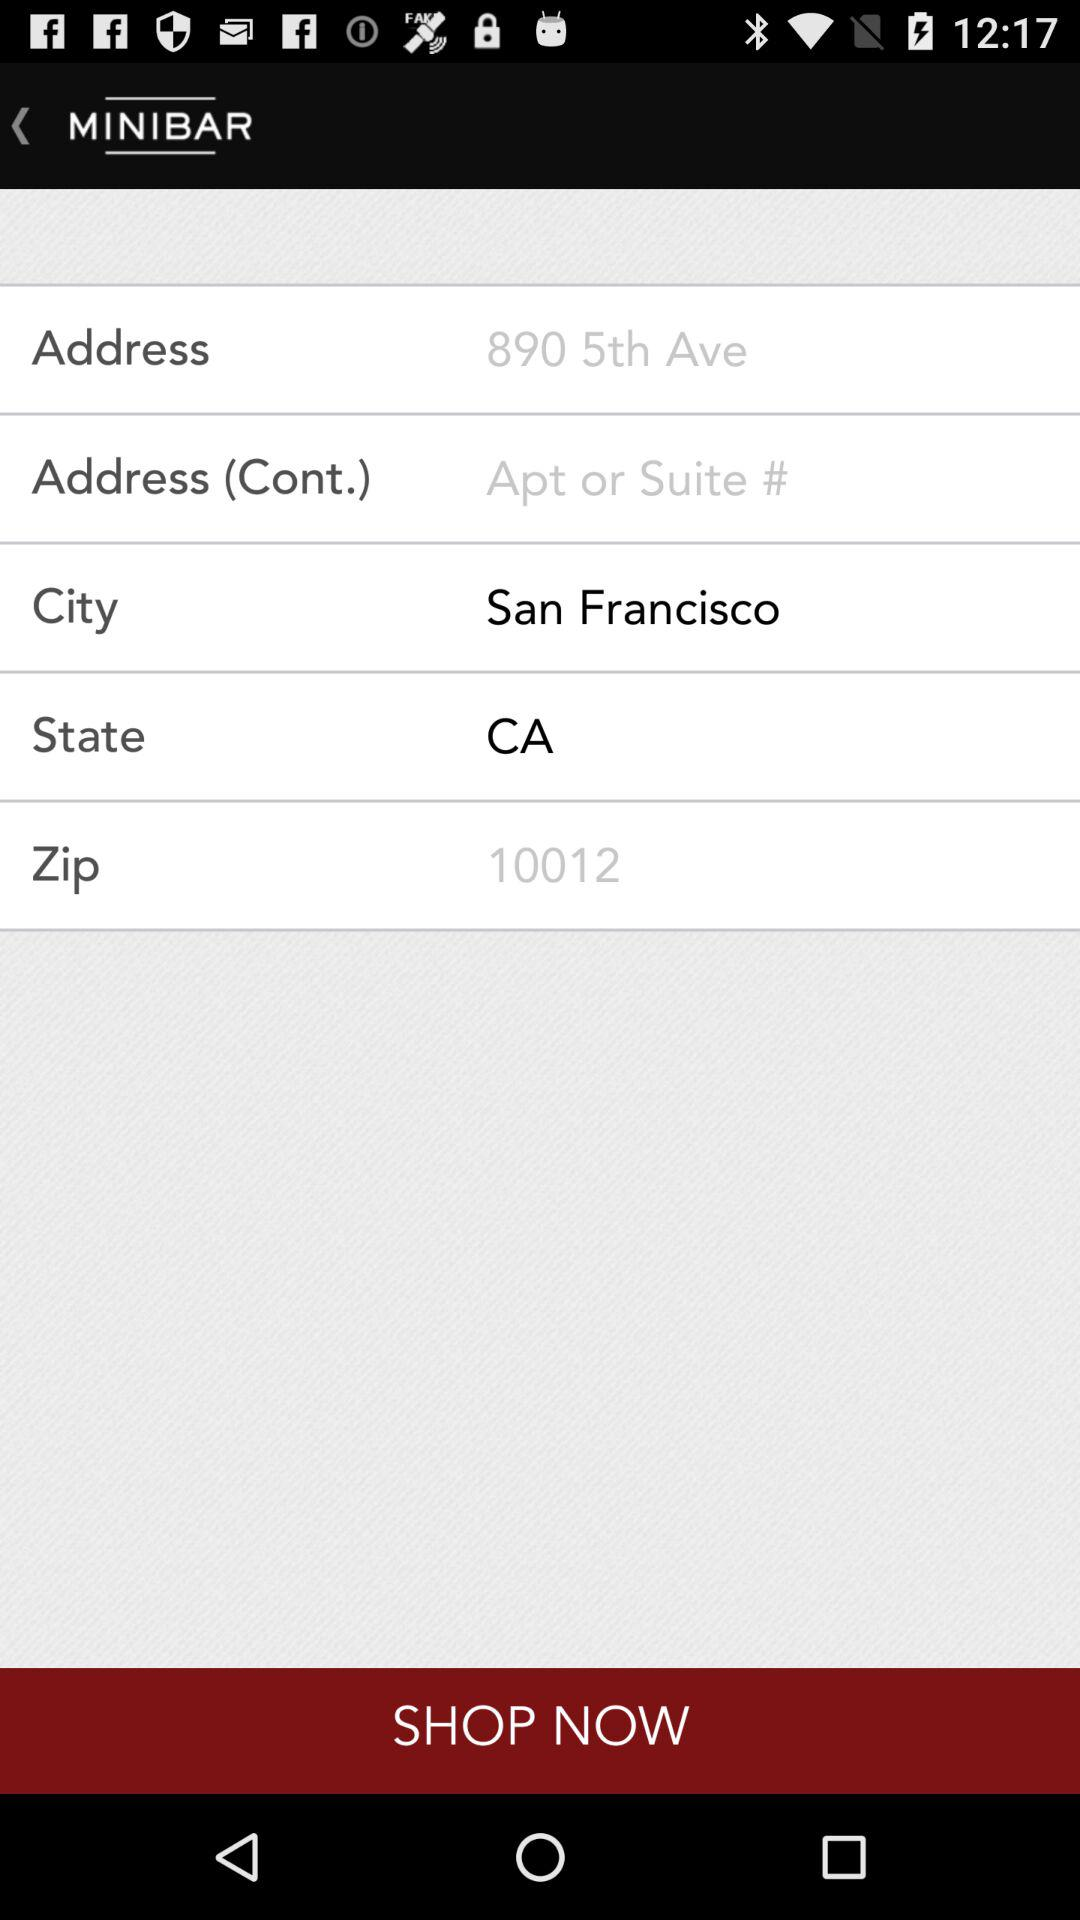What is the selected state? The selected state is California. 